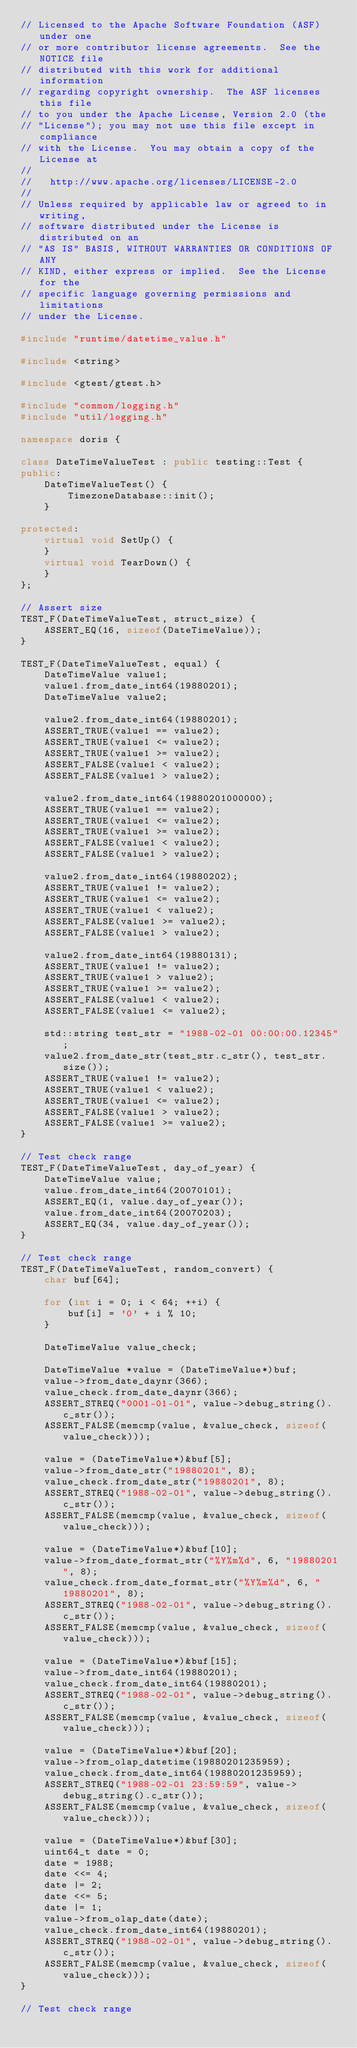<code> <loc_0><loc_0><loc_500><loc_500><_C++_>// Licensed to the Apache Software Foundation (ASF) under one
// or more contributor license agreements.  See the NOTICE file
// distributed with this work for additional information
// regarding copyright ownership.  The ASF licenses this file
// to you under the Apache License, Version 2.0 (the
// "License"); you may not use this file except in compliance
// with the License.  You may obtain a copy of the License at
//
//   http://www.apache.org/licenses/LICENSE-2.0
//
// Unless required by applicable law or agreed to in writing,
// software distributed under the License is distributed on an
// "AS IS" BASIS, WITHOUT WARRANTIES OR CONDITIONS OF ANY
// KIND, either express or implied.  See the License for the
// specific language governing permissions and limitations
// under the License.

#include "runtime/datetime_value.h"

#include <string>

#include <gtest/gtest.h>

#include "common/logging.h"
#include "util/logging.h"

namespace doris {

class DateTimeValueTest : public testing::Test {
public:
    DateTimeValueTest() {
        TimezoneDatabase::init();
    }

protected:
    virtual void SetUp() {
    }
    virtual void TearDown() {
    }
};

// Assert size
TEST_F(DateTimeValueTest, struct_size) {
    ASSERT_EQ(16, sizeof(DateTimeValue));
}

TEST_F(DateTimeValueTest, equal) {
    DateTimeValue value1;
    value1.from_date_int64(19880201);
    DateTimeValue value2;

    value2.from_date_int64(19880201);
    ASSERT_TRUE(value1 == value2);
    ASSERT_TRUE(value1 <= value2);
    ASSERT_TRUE(value1 >= value2);
    ASSERT_FALSE(value1 < value2);
    ASSERT_FALSE(value1 > value2);

    value2.from_date_int64(19880201000000);
    ASSERT_TRUE(value1 == value2);
    ASSERT_TRUE(value1 <= value2);
    ASSERT_TRUE(value1 >= value2);
    ASSERT_FALSE(value1 < value2);
    ASSERT_FALSE(value1 > value2);

    value2.from_date_int64(19880202);
    ASSERT_TRUE(value1 != value2);
    ASSERT_TRUE(value1 <= value2);
    ASSERT_TRUE(value1 < value2);
    ASSERT_FALSE(value1 >= value2);
    ASSERT_FALSE(value1 > value2);

    value2.from_date_int64(19880131);
    ASSERT_TRUE(value1 != value2);
    ASSERT_TRUE(value1 > value2);
    ASSERT_TRUE(value1 >= value2);
    ASSERT_FALSE(value1 < value2);
    ASSERT_FALSE(value1 <= value2);

    std::string test_str = "1988-02-01 00:00:00.12345";
    value2.from_date_str(test_str.c_str(), test_str.size());
    ASSERT_TRUE(value1 != value2);
    ASSERT_TRUE(value1 < value2);
    ASSERT_TRUE(value1 <= value2);
    ASSERT_FALSE(value1 > value2);
    ASSERT_FALSE(value1 >= value2);
}

// Test check range
TEST_F(DateTimeValueTest, day_of_year) {
    DateTimeValue value;
    value.from_date_int64(20070101);
    ASSERT_EQ(1, value.day_of_year());
    value.from_date_int64(20070203);
    ASSERT_EQ(34, value.day_of_year());
}

// Test check range
TEST_F(DateTimeValueTest, random_convert) {
    char buf[64];

    for (int i = 0; i < 64; ++i) {
        buf[i] = '0' + i % 10;
    }

    DateTimeValue value_check;

    DateTimeValue *value = (DateTimeValue*)buf;
    value->from_date_daynr(366);
    value_check.from_date_daynr(366);
    ASSERT_STREQ("0001-01-01", value->debug_string().c_str());
    ASSERT_FALSE(memcmp(value, &value_check, sizeof(value_check)));

    value = (DateTimeValue*)&buf[5];
    value->from_date_str("19880201", 8);
    value_check.from_date_str("19880201", 8);
    ASSERT_STREQ("1988-02-01", value->debug_string().c_str());
    ASSERT_FALSE(memcmp(value, &value_check, sizeof(value_check)));

    value = (DateTimeValue*)&buf[10];
    value->from_date_format_str("%Y%m%d", 6, "19880201", 8);
    value_check.from_date_format_str("%Y%m%d", 6, "19880201", 8);
    ASSERT_STREQ("1988-02-01", value->debug_string().c_str());
    ASSERT_FALSE(memcmp(value, &value_check, sizeof(value_check)));

    value = (DateTimeValue*)&buf[15];
    value->from_date_int64(19880201);
    value_check.from_date_int64(19880201);
    ASSERT_STREQ("1988-02-01", value->debug_string().c_str());
    ASSERT_FALSE(memcmp(value, &value_check, sizeof(value_check)));

    value = (DateTimeValue*)&buf[20];
    value->from_olap_datetime(19880201235959);
    value_check.from_date_int64(19880201235959);
    ASSERT_STREQ("1988-02-01 23:59:59", value->debug_string().c_str());
    ASSERT_FALSE(memcmp(value, &value_check, sizeof(value_check)));

    value = (DateTimeValue*)&buf[30];
    uint64_t date = 0;
    date = 1988;
    date <<= 4;
    date |= 2;
    date <<= 5;
    date |= 1;
    value->from_olap_date(date);
    value_check.from_date_int64(19880201);
    ASSERT_STREQ("1988-02-01", value->debug_string().c_str());
    ASSERT_FALSE(memcmp(value, &value_check, sizeof(value_check)));
}

// Test check range</code> 